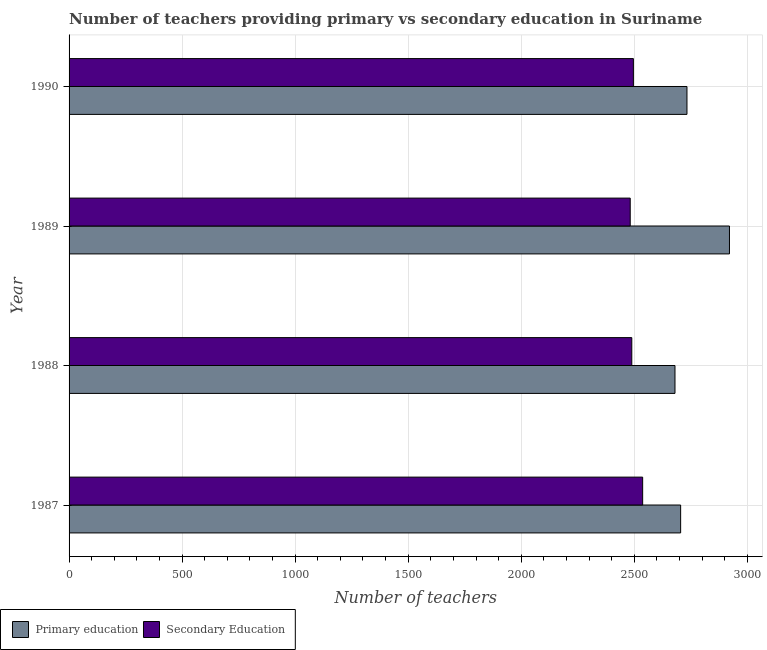How many different coloured bars are there?
Give a very brief answer. 2. Are the number of bars on each tick of the Y-axis equal?
Provide a succinct answer. Yes. What is the label of the 3rd group of bars from the top?
Make the answer very short. 1988. What is the number of primary teachers in 1987?
Offer a very short reply. 2705. Across all years, what is the maximum number of primary teachers?
Ensure brevity in your answer.  2921. Across all years, what is the minimum number of secondary teachers?
Ensure brevity in your answer.  2482. In which year was the number of secondary teachers minimum?
Your answer should be very brief. 1989. What is the total number of primary teachers in the graph?
Provide a short and direct response. 1.10e+04. What is the difference between the number of primary teachers in 1989 and that in 1990?
Your answer should be compact. 188. What is the difference between the number of primary teachers in 1990 and the number of secondary teachers in 1988?
Offer a very short reply. 244. What is the average number of secondary teachers per year?
Give a very brief answer. 2501. In the year 1987, what is the difference between the number of primary teachers and number of secondary teachers?
Ensure brevity in your answer.  168. In how many years, is the number of secondary teachers greater than 1800 ?
Your response must be concise. 4. What is the ratio of the number of primary teachers in 1987 to that in 1988?
Offer a terse response. 1.01. What is the difference between the highest and the second highest number of secondary teachers?
Your answer should be very brief. 41. What is the difference between the highest and the lowest number of primary teachers?
Your response must be concise. 241. What does the 1st bar from the top in 1988 represents?
Offer a terse response. Secondary Education. What does the 2nd bar from the bottom in 1990 represents?
Give a very brief answer. Secondary Education. How many bars are there?
Give a very brief answer. 8. Are all the bars in the graph horizontal?
Provide a succinct answer. Yes. Are the values on the major ticks of X-axis written in scientific E-notation?
Provide a succinct answer. No. Does the graph contain any zero values?
Ensure brevity in your answer.  No. How many legend labels are there?
Your answer should be very brief. 2. What is the title of the graph?
Keep it short and to the point. Number of teachers providing primary vs secondary education in Suriname. What is the label or title of the X-axis?
Keep it short and to the point. Number of teachers. What is the label or title of the Y-axis?
Offer a very short reply. Year. What is the Number of teachers of Primary education in 1987?
Keep it short and to the point. 2705. What is the Number of teachers in Secondary Education in 1987?
Offer a terse response. 2537. What is the Number of teachers of Primary education in 1988?
Give a very brief answer. 2680. What is the Number of teachers in Secondary Education in 1988?
Make the answer very short. 2489. What is the Number of teachers in Primary education in 1989?
Ensure brevity in your answer.  2921. What is the Number of teachers of Secondary Education in 1989?
Offer a very short reply. 2482. What is the Number of teachers of Primary education in 1990?
Ensure brevity in your answer.  2733. What is the Number of teachers of Secondary Education in 1990?
Your response must be concise. 2496. Across all years, what is the maximum Number of teachers of Primary education?
Ensure brevity in your answer.  2921. Across all years, what is the maximum Number of teachers in Secondary Education?
Keep it short and to the point. 2537. Across all years, what is the minimum Number of teachers in Primary education?
Keep it short and to the point. 2680. Across all years, what is the minimum Number of teachers of Secondary Education?
Offer a very short reply. 2482. What is the total Number of teachers in Primary education in the graph?
Your answer should be very brief. 1.10e+04. What is the total Number of teachers in Secondary Education in the graph?
Offer a terse response. 1.00e+04. What is the difference between the Number of teachers in Primary education in 1987 and that in 1988?
Your response must be concise. 25. What is the difference between the Number of teachers in Secondary Education in 1987 and that in 1988?
Your answer should be compact. 48. What is the difference between the Number of teachers of Primary education in 1987 and that in 1989?
Provide a succinct answer. -216. What is the difference between the Number of teachers in Primary education in 1988 and that in 1989?
Provide a short and direct response. -241. What is the difference between the Number of teachers of Secondary Education in 1988 and that in 1989?
Give a very brief answer. 7. What is the difference between the Number of teachers in Primary education in 1988 and that in 1990?
Ensure brevity in your answer.  -53. What is the difference between the Number of teachers of Secondary Education in 1988 and that in 1990?
Keep it short and to the point. -7. What is the difference between the Number of teachers in Primary education in 1989 and that in 1990?
Provide a short and direct response. 188. What is the difference between the Number of teachers in Primary education in 1987 and the Number of teachers in Secondary Education in 1988?
Give a very brief answer. 216. What is the difference between the Number of teachers in Primary education in 1987 and the Number of teachers in Secondary Education in 1989?
Provide a short and direct response. 223. What is the difference between the Number of teachers in Primary education in 1987 and the Number of teachers in Secondary Education in 1990?
Your response must be concise. 209. What is the difference between the Number of teachers of Primary education in 1988 and the Number of teachers of Secondary Education in 1989?
Provide a succinct answer. 198. What is the difference between the Number of teachers of Primary education in 1988 and the Number of teachers of Secondary Education in 1990?
Your response must be concise. 184. What is the difference between the Number of teachers in Primary education in 1989 and the Number of teachers in Secondary Education in 1990?
Provide a succinct answer. 425. What is the average Number of teachers in Primary education per year?
Give a very brief answer. 2759.75. What is the average Number of teachers in Secondary Education per year?
Make the answer very short. 2501. In the year 1987, what is the difference between the Number of teachers in Primary education and Number of teachers in Secondary Education?
Provide a short and direct response. 168. In the year 1988, what is the difference between the Number of teachers of Primary education and Number of teachers of Secondary Education?
Your answer should be very brief. 191. In the year 1989, what is the difference between the Number of teachers of Primary education and Number of teachers of Secondary Education?
Provide a short and direct response. 439. In the year 1990, what is the difference between the Number of teachers of Primary education and Number of teachers of Secondary Education?
Keep it short and to the point. 237. What is the ratio of the Number of teachers in Primary education in 1987 to that in 1988?
Provide a succinct answer. 1.01. What is the ratio of the Number of teachers in Secondary Education in 1987 to that in 1988?
Ensure brevity in your answer.  1.02. What is the ratio of the Number of teachers in Primary education in 1987 to that in 1989?
Your response must be concise. 0.93. What is the ratio of the Number of teachers in Secondary Education in 1987 to that in 1989?
Your answer should be very brief. 1.02. What is the ratio of the Number of teachers in Primary education in 1987 to that in 1990?
Provide a succinct answer. 0.99. What is the ratio of the Number of teachers of Secondary Education in 1987 to that in 1990?
Your response must be concise. 1.02. What is the ratio of the Number of teachers in Primary education in 1988 to that in 1989?
Give a very brief answer. 0.92. What is the ratio of the Number of teachers in Secondary Education in 1988 to that in 1989?
Keep it short and to the point. 1. What is the ratio of the Number of teachers in Primary education in 1988 to that in 1990?
Make the answer very short. 0.98. What is the ratio of the Number of teachers of Secondary Education in 1988 to that in 1990?
Keep it short and to the point. 1. What is the ratio of the Number of teachers of Primary education in 1989 to that in 1990?
Give a very brief answer. 1.07. What is the ratio of the Number of teachers of Secondary Education in 1989 to that in 1990?
Offer a terse response. 0.99. What is the difference between the highest and the second highest Number of teachers in Primary education?
Provide a succinct answer. 188. What is the difference between the highest and the second highest Number of teachers in Secondary Education?
Your response must be concise. 41. What is the difference between the highest and the lowest Number of teachers of Primary education?
Make the answer very short. 241. 